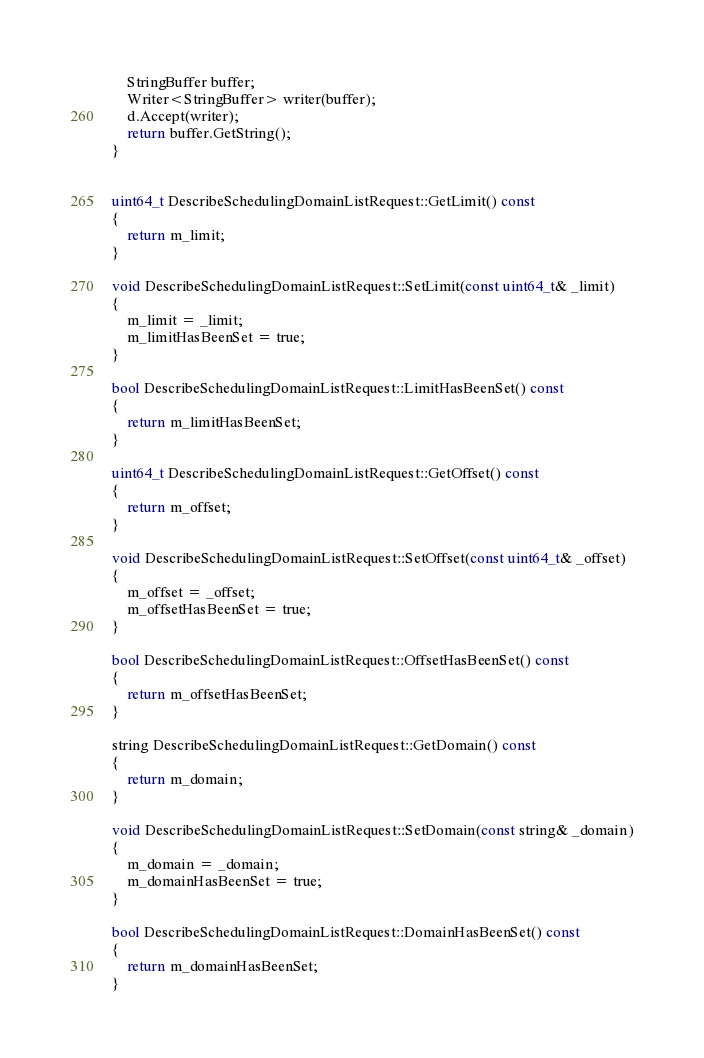<code> <loc_0><loc_0><loc_500><loc_500><_C++_>
    StringBuffer buffer;
    Writer<StringBuffer> writer(buffer);
    d.Accept(writer);
    return buffer.GetString();
}


uint64_t DescribeSchedulingDomainListRequest::GetLimit() const
{
    return m_limit;
}

void DescribeSchedulingDomainListRequest::SetLimit(const uint64_t& _limit)
{
    m_limit = _limit;
    m_limitHasBeenSet = true;
}

bool DescribeSchedulingDomainListRequest::LimitHasBeenSet() const
{
    return m_limitHasBeenSet;
}

uint64_t DescribeSchedulingDomainListRequest::GetOffset() const
{
    return m_offset;
}

void DescribeSchedulingDomainListRequest::SetOffset(const uint64_t& _offset)
{
    m_offset = _offset;
    m_offsetHasBeenSet = true;
}

bool DescribeSchedulingDomainListRequest::OffsetHasBeenSet() const
{
    return m_offsetHasBeenSet;
}

string DescribeSchedulingDomainListRequest::GetDomain() const
{
    return m_domain;
}

void DescribeSchedulingDomainListRequest::SetDomain(const string& _domain)
{
    m_domain = _domain;
    m_domainHasBeenSet = true;
}

bool DescribeSchedulingDomainListRequest::DomainHasBeenSet() const
{
    return m_domainHasBeenSet;
}


</code> 